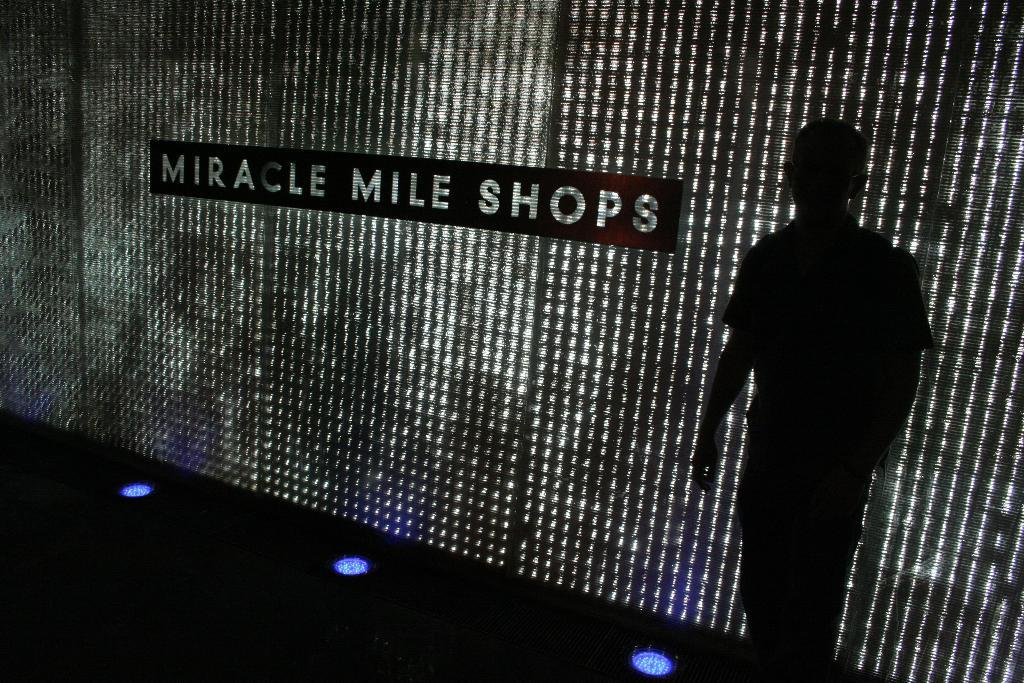What is the main subject of the image? There is a man standing in the image. What can be seen in the background of the image? There is text on a wall in the background of the image. What type of lighting is present in the image? There are lights at the bottom of the image. What type of breakfast is being served on the seashore in the image? There is no breakfast or seashore present in the image; it features a man standing with text on a wall in the background and lights at the bottom. 